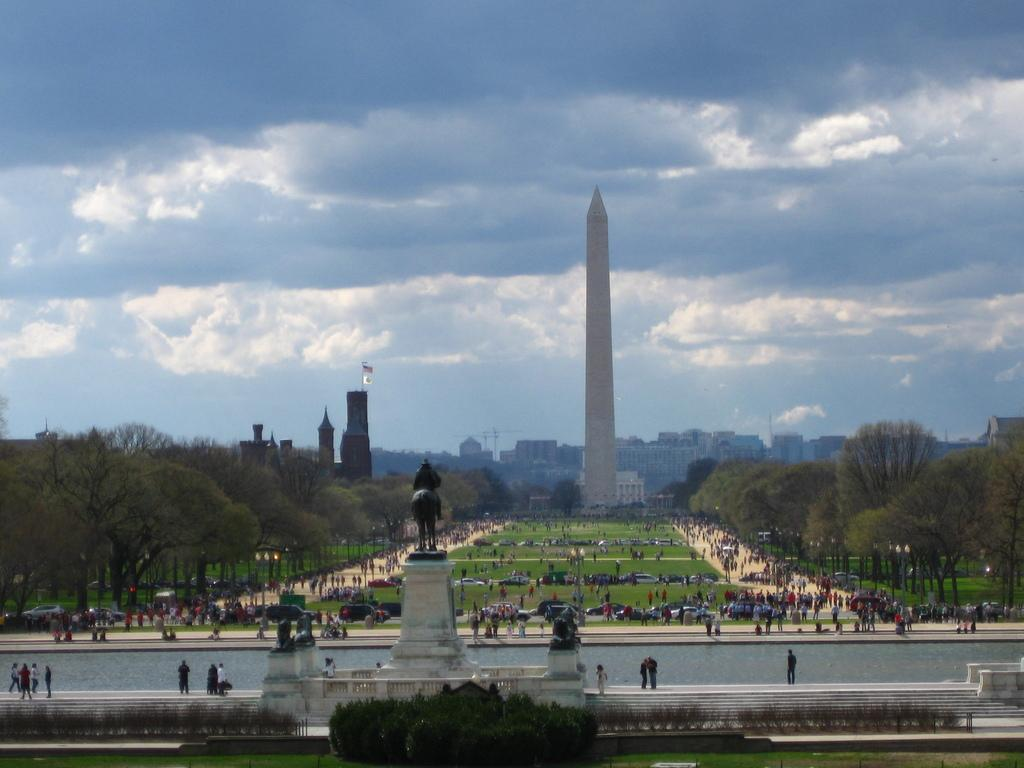What can be seen in the background of the image? In the background of the image, there is a sky, buildings, a tower crane, and trees. Can you describe the setting of the image? The image features people, towers, vehicles, statues, stairs, pedestals, grass, and water, all set against the backdrop of the background elements. What type of objects are present in the image? There are objects such as the tower crane, statues, and pedestals visible in the image. What type of fiction can be seen in the image? There is no fiction present in the image; it is a realistic scene featuring various elements such as buildings, people, and vehicles. Can you see any stars in the image? There are no stars visible in the image; it features a sky, but not stars. Is there a nest in the image? There is no nest present in the image. 